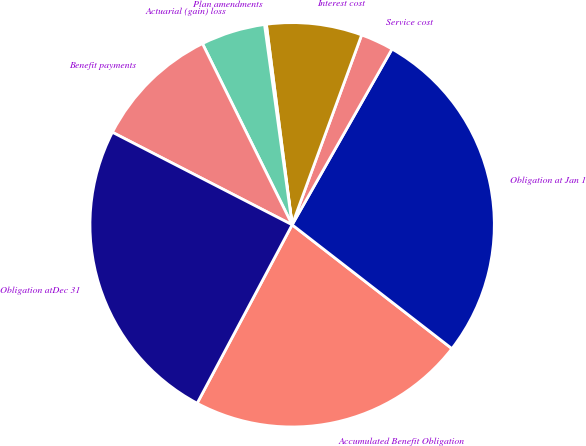<chart> <loc_0><loc_0><loc_500><loc_500><pie_chart><fcel>Accumulated Benefit Obligation<fcel>Obligation at Jan 1<fcel>Service cost<fcel>Interest cost<fcel>Plan amendments<fcel>Actuarial (gain) loss<fcel>Benefit payments<fcel>Obligation atDec 31<nl><fcel>22.29%<fcel>27.27%<fcel>2.64%<fcel>7.62%<fcel>0.15%<fcel>5.13%<fcel>10.12%<fcel>24.78%<nl></chart> 